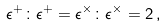Convert formula to latex. <formula><loc_0><loc_0><loc_500><loc_500>\epsilon ^ { + } \colon \epsilon ^ { + } = \epsilon ^ { \times } \colon \epsilon ^ { \times } = 2 \, ,</formula> 